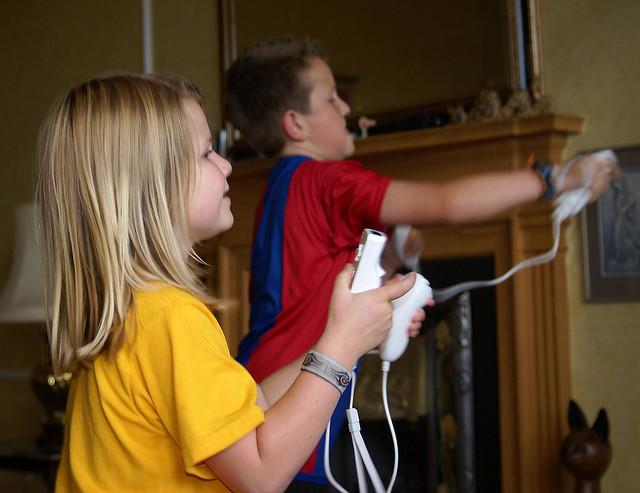How are the women similarly dressed?
Give a very brief answer. Shirts. Does this girl have red hair?
Give a very brief answer. No. Are these people young?
Keep it brief. Yes. What color is the girl's shirt?
Keep it brief. Yellow. What game are these children playing?
Short answer required. Wii. Does this child have long hair?
Be succinct. Yes. What is the kid doing?
Concise answer only. Playing wii. 